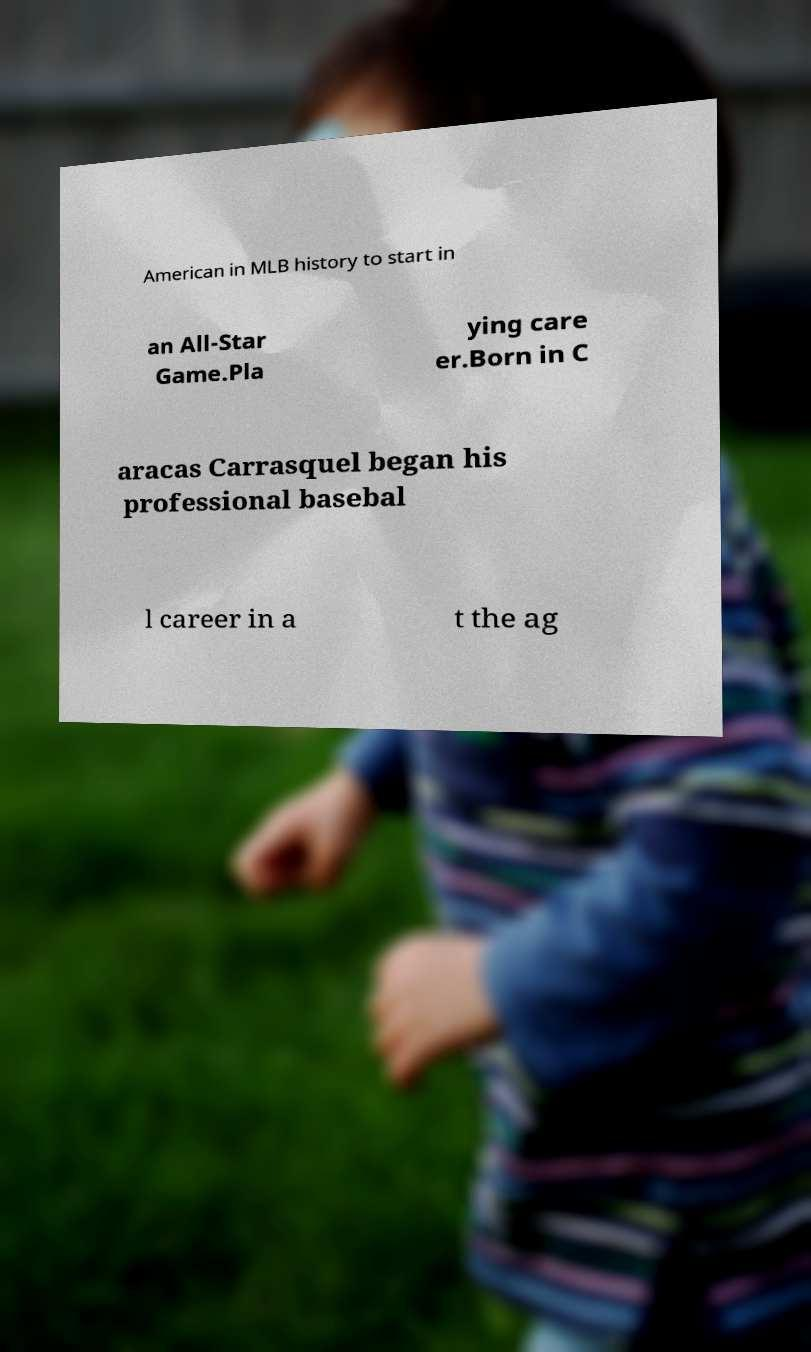Please identify and transcribe the text found in this image. American in MLB history to start in an All-Star Game.Pla ying care er.Born in C aracas Carrasquel began his professional basebal l career in a t the ag 